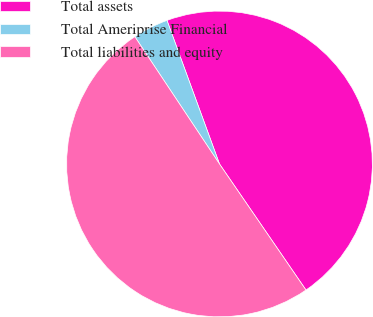<chart> <loc_0><loc_0><loc_500><loc_500><pie_chart><fcel>Total assets<fcel>Total Ameriprise Financial<fcel>Total liabilities and equity<nl><fcel>46.01%<fcel>3.76%<fcel>50.23%<nl></chart> 